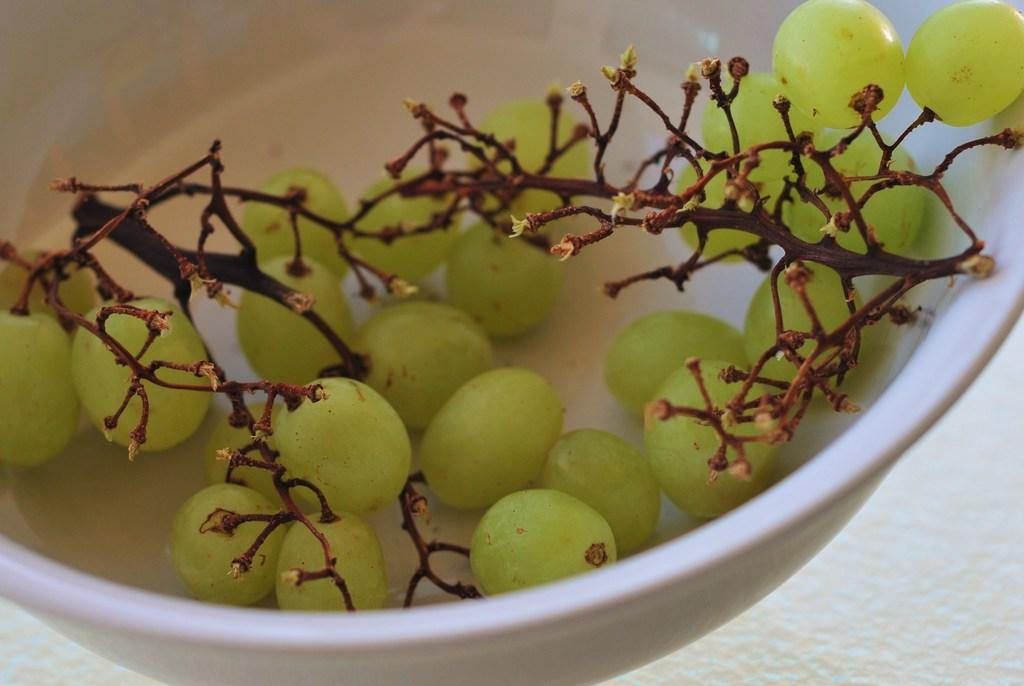What color is the bowl in the image? The bowl in the image is white. What is inside the bowl? The bowl contains grapes. What type of temper does the bowl have in the image? The bowl does not have a temper, as it is an inanimate object. 